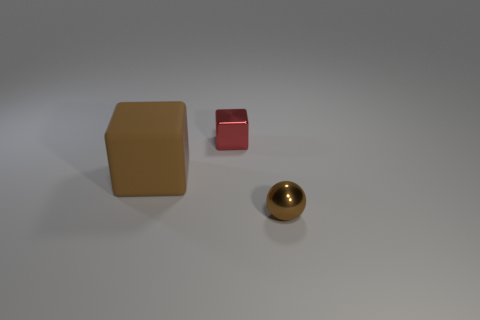Is there another brown rubber object of the same shape as the brown rubber object?
Offer a very short reply. No. Are there the same number of metallic things that are on the left side of the brown sphere and small shiny cubes behind the tiny red block?
Your answer should be very brief. No. Do the small shiny object that is behind the brown shiny ball and the big brown object have the same shape?
Ensure brevity in your answer.  Yes. Is the brown rubber object the same shape as the red object?
Provide a succinct answer. Yes. How many metallic things are either large brown things or small objects?
Keep it short and to the point. 2. There is a big cube that is the same color as the ball; what material is it?
Provide a succinct answer. Rubber. Does the metal block have the same size as the matte cube?
Your response must be concise. No. How many things are either purple shiny balls or small shiny objects behind the shiny sphere?
Your response must be concise. 1. What is the material of the thing that is the same size as the shiny cube?
Keep it short and to the point. Metal. What is the material of the thing that is in front of the tiny red object and on the left side of the small shiny ball?
Provide a short and direct response. Rubber. 